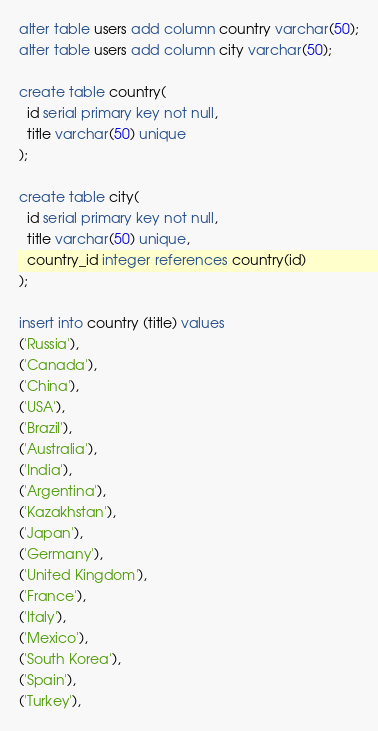<code> <loc_0><loc_0><loc_500><loc_500><_SQL_>alter table users add column country varchar(50);
alter table users add column city varchar(50);

create table country(
  id serial primary key not null,
  title varchar(50) unique
);

create table city(
  id serial primary key not null,
  title varchar(50) unique,
  country_id integer references country(id)
);

insert into country (title) values
('Russia'),
('Canada'),
('China'),
('USA'),
('Brazil'),
('Australia'),
('India'),
('Argentina'),
('Kazakhstan'),
('Japan'),
('Germany'),
('United Kingdom'),
('France'),
('Italy'),
('Mexico'),
('South Korea'),
('Spain'),
('Turkey'),</code> 